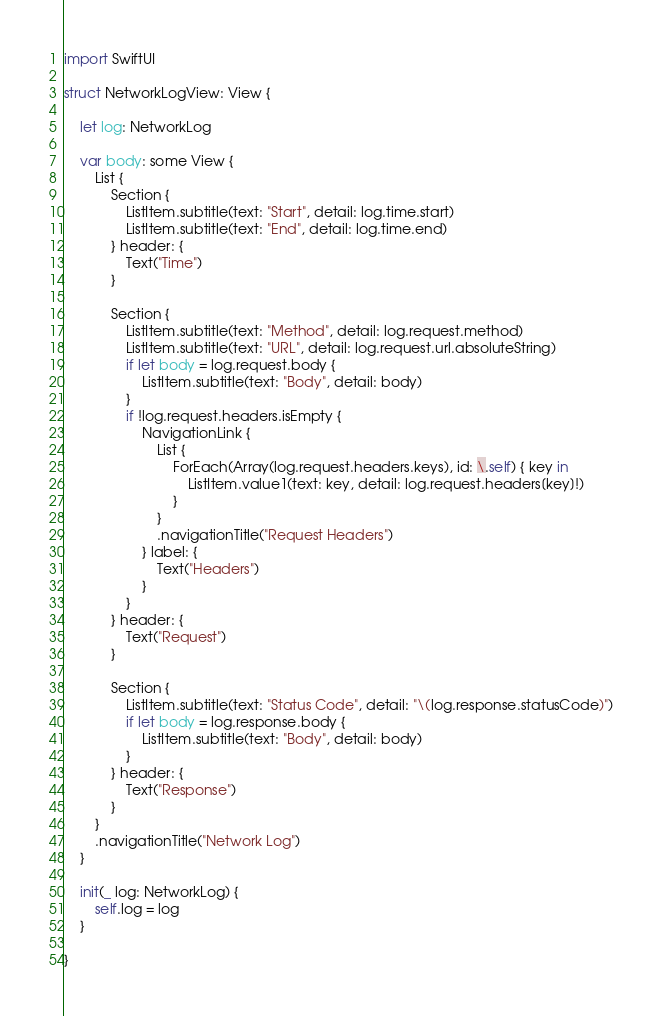<code> <loc_0><loc_0><loc_500><loc_500><_Swift_>import SwiftUI

struct NetworkLogView: View {

    let log: NetworkLog

    var body: some View {
        List {
            Section {
                ListItem.subtitle(text: "Start", detail: log.time.start)
                ListItem.subtitle(text: "End", detail: log.time.end)
            } header: {
                Text("Time")
            }

            Section {
                ListItem.subtitle(text: "Method", detail: log.request.method)
                ListItem.subtitle(text: "URL", detail: log.request.url.absoluteString)
                if let body = log.request.body {
                    ListItem.subtitle(text: "Body", detail: body)
                }
                if !log.request.headers.isEmpty {
                    NavigationLink {
                        List {
                            ForEach(Array(log.request.headers.keys), id: \.self) { key in
                                ListItem.value1(text: key, detail: log.request.headers[key]!)
                            }
                        }
                        .navigationTitle("Request Headers")
                    } label: {
                        Text("Headers")
                    }
                }
            } header: {
                Text("Request")
            }

            Section {
                ListItem.subtitle(text: "Status Code", detail: "\(log.response.statusCode)")
                if let body = log.response.body {
                    ListItem.subtitle(text: "Body", detail: body)
                }
            } header: {
                Text("Response")
            }
        }
        .navigationTitle("Network Log")
    }

    init(_ log: NetworkLog) {
        self.log = log
    }

}
</code> 